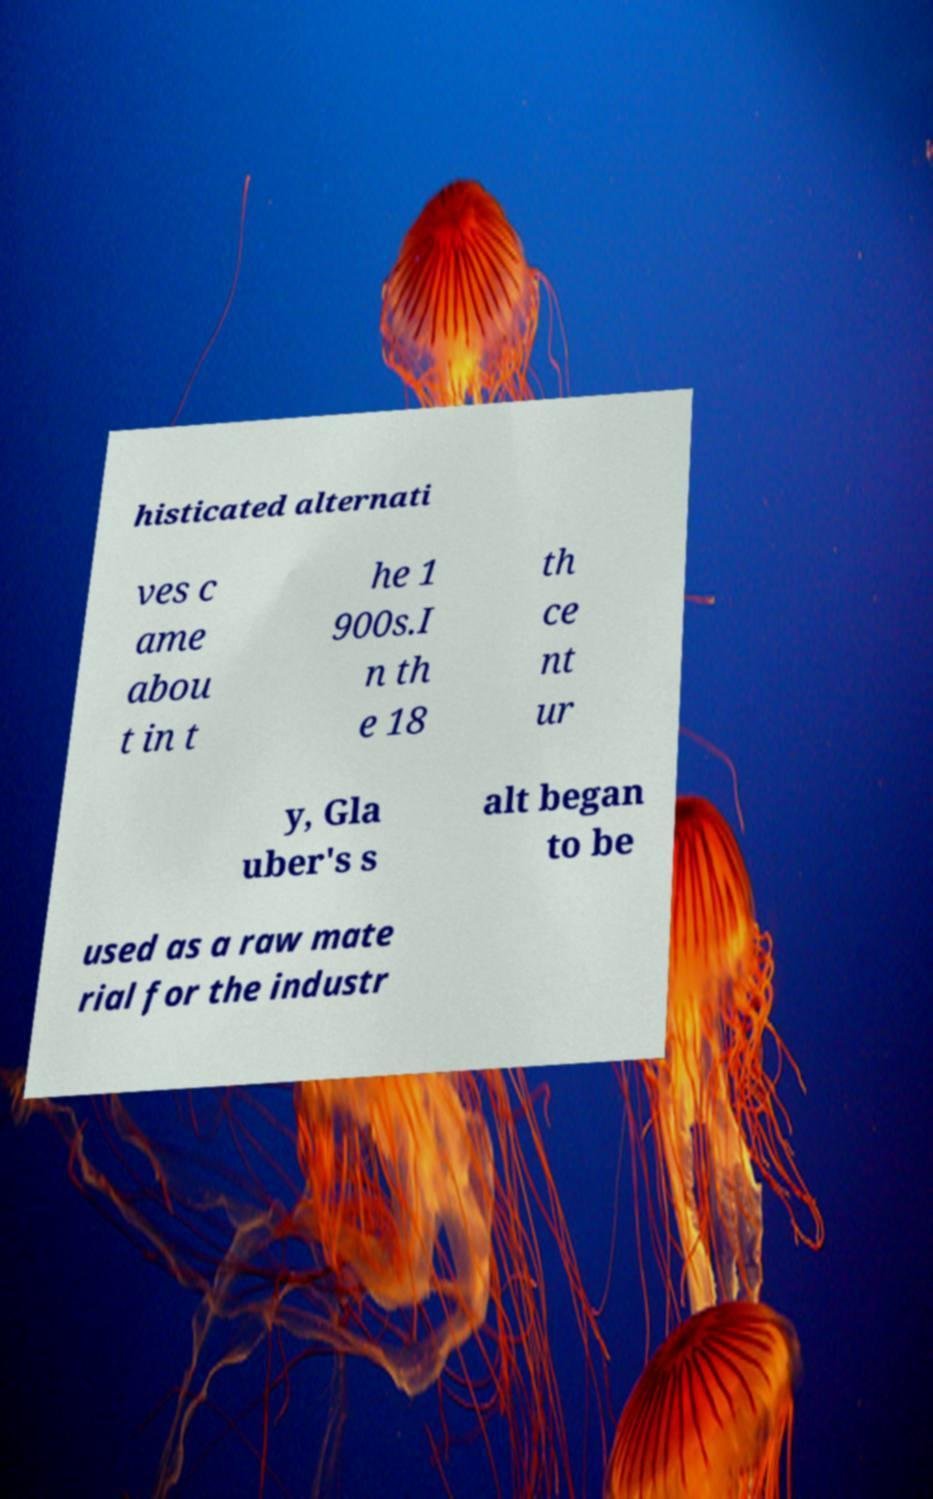I need the written content from this picture converted into text. Can you do that? histicated alternati ves c ame abou t in t he 1 900s.I n th e 18 th ce nt ur y, Gla uber's s alt began to be used as a raw mate rial for the industr 